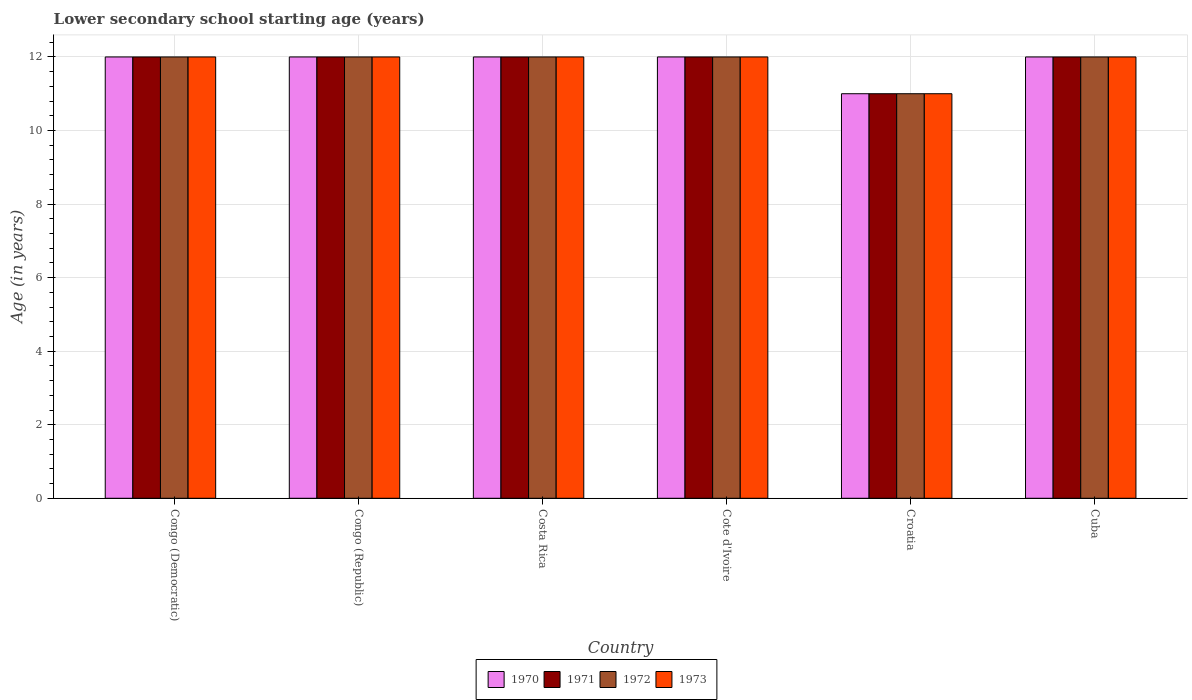How many different coloured bars are there?
Offer a terse response. 4. Are the number of bars on each tick of the X-axis equal?
Offer a very short reply. Yes. How many bars are there on the 4th tick from the left?
Offer a very short reply. 4. How many bars are there on the 4th tick from the right?
Offer a terse response. 4. What is the label of the 6th group of bars from the left?
Your answer should be very brief. Cuba. In how many cases, is the number of bars for a given country not equal to the number of legend labels?
Keep it short and to the point. 0. What is the lower secondary school starting age of children in 1972 in Congo (Democratic)?
Your answer should be very brief. 12. Across all countries, what is the maximum lower secondary school starting age of children in 1971?
Offer a very short reply. 12. In which country was the lower secondary school starting age of children in 1971 maximum?
Your answer should be very brief. Congo (Democratic). In which country was the lower secondary school starting age of children in 1970 minimum?
Keep it short and to the point. Croatia. What is the total lower secondary school starting age of children in 1973 in the graph?
Provide a succinct answer. 71. What is the difference between the lower secondary school starting age of children in 1971 in Costa Rica and that in Cote d'Ivoire?
Ensure brevity in your answer.  0. What is the average lower secondary school starting age of children in 1970 per country?
Ensure brevity in your answer.  11.83. What is the difference between the lower secondary school starting age of children of/in 1970 and lower secondary school starting age of children of/in 1973 in Congo (Democratic)?
Provide a succinct answer. 0. In how many countries, is the lower secondary school starting age of children in 1972 greater than 10.4 years?
Your response must be concise. 6. What is the ratio of the lower secondary school starting age of children in 1970 in Cote d'Ivoire to that in Cuba?
Keep it short and to the point. 1. Is the lower secondary school starting age of children in 1973 in Cote d'Ivoire less than that in Croatia?
Offer a very short reply. No. Is the difference between the lower secondary school starting age of children in 1970 in Costa Rica and Croatia greater than the difference between the lower secondary school starting age of children in 1973 in Costa Rica and Croatia?
Provide a succinct answer. No. In how many countries, is the lower secondary school starting age of children in 1973 greater than the average lower secondary school starting age of children in 1973 taken over all countries?
Offer a very short reply. 5. Is the sum of the lower secondary school starting age of children in 1972 in Costa Rica and Cuba greater than the maximum lower secondary school starting age of children in 1970 across all countries?
Make the answer very short. Yes. Is it the case that in every country, the sum of the lower secondary school starting age of children in 1973 and lower secondary school starting age of children in 1971 is greater than the sum of lower secondary school starting age of children in 1970 and lower secondary school starting age of children in 1972?
Ensure brevity in your answer.  No. What does the 4th bar from the right in Cuba represents?
Offer a terse response. 1970. How many bars are there?
Provide a succinct answer. 24. Are all the bars in the graph horizontal?
Keep it short and to the point. No. How many countries are there in the graph?
Offer a terse response. 6. What is the difference between two consecutive major ticks on the Y-axis?
Your response must be concise. 2. Does the graph contain any zero values?
Offer a very short reply. No. Where does the legend appear in the graph?
Make the answer very short. Bottom center. How many legend labels are there?
Give a very brief answer. 4. What is the title of the graph?
Make the answer very short. Lower secondary school starting age (years). Does "1986" appear as one of the legend labels in the graph?
Make the answer very short. No. What is the label or title of the X-axis?
Keep it short and to the point. Country. What is the label or title of the Y-axis?
Your response must be concise. Age (in years). What is the Age (in years) in 1973 in Congo (Republic)?
Give a very brief answer. 12. What is the Age (in years) in 1971 in Costa Rica?
Provide a succinct answer. 12. What is the Age (in years) of 1972 in Costa Rica?
Keep it short and to the point. 12. What is the Age (in years) in 1971 in Cuba?
Your answer should be compact. 12. What is the Age (in years) in 1973 in Cuba?
Provide a short and direct response. 12. Across all countries, what is the maximum Age (in years) of 1973?
Your answer should be very brief. 12. Across all countries, what is the minimum Age (in years) of 1970?
Offer a terse response. 11. Across all countries, what is the minimum Age (in years) of 1971?
Ensure brevity in your answer.  11. Across all countries, what is the minimum Age (in years) of 1973?
Provide a succinct answer. 11. What is the total Age (in years) in 1970 in the graph?
Your answer should be very brief. 71. What is the total Age (in years) of 1972 in the graph?
Give a very brief answer. 71. What is the difference between the Age (in years) of 1970 in Congo (Democratic) and that in Congo (Republic)?
Provide a short and direct response. 0. What is the difference between the Age (in years) of 1971 in Congo (Democratic) and that in Congo (Republic)?
Make the answer very short. 0. What is the difference between the Age (in years) in 1972 in Congo (Democratic) and that in Congo (Republic)?
Give a very brief answer. 0. What is the difference between the Age (in years) of 1973 in Congo (Democratic) and that in Congo (Republic)?
Your answer should be very brief. 0. What is the difference between the Age (in years) in 1970 in Congo (Democratic) and that in Costa Rica?
Your response must be concise. 0. What is the difference between the Age (in years) of 1972 in Congo (Democratic) and that in Costa Rica?
Offer a very short reply. 0. What is the difference between the Age (in years) of 1971 in Congo (Democratic) and that in Cote d'Ivoire?
Provide a short and direct response. 0. What is the difference between the Age (in years) of 1972 in Congo (Democratic) and that in Cote d'Ivoire?
Offer a very short reply. 0. What is the difference between the Age (in years) in 1973 in Congo (Democratic) and that in Cote d'Ivoire?
Offer a very short reply. 0. What is the difference between the Age (in years) of 1971 in Congo (Democratic) and that in Croatia?
Your answer should be very brief. 1. What is the difference between the Age (in years) in 1972 in Congo (Democratic) and that in Croatia?
Your answer should be very brief. 1. What is the difference between the Age (in years) in 1973 in Congo (Democratic) and that in Croatia?
Give a very brief answer. 1. What is the difference between the Age (in years) in 1970 in Congo (Democratic) and that in Cuba?
Your response must be concise. 0. What is the difference between the Age (in years) of 1971 in Congo (Democratic) and that in Cuba?
Your answer should be very brief. 0. What is the difference between the Age (in years) in 1972 in Congo (Democratic) and that in Cuba?
Keep it short and to the point. 0. What is the difference between the Age (in years) in 1970 in Congo (Republic) and that in Costa Rica?
Offer a very short reply. 0. What is the difference between the Age (in years) in 1972 in Congo (Republic) and that in Costa Rica?
Your answer should be compact. 0. What is the difference between the Age (in years) in 1973 in Congo (Republic) and that in Costa Rica?
Offer a very short reply. 0. What is the difference between the Age (in years) in 1973 in Congo (Republic) and that in Cote d'Ivoire?
Provide a short and direct response. 0. What is the difference between the Age (in years) of 1970 in Congo (Republic) and that in Croatia?
Offer a very short reply. 1. What is the difference between the Age (in years) of 1971 in Congo (Republic) and that in Croatia?
Provide a short and direct response. 1. What is the difference between the Age (in years) of 1970 in Congo (Republic) and that in Cuba?
Your answer should be compact. 0. What is the difference between the Age (in years) of 1971 in Congo (Republic) and that in Cuba?
Give a very brief answer. 0. What is the difference between the Age (in years) of 1972 in Congo (Republic) and that in Cuba?
Your answer should be very brief. 0. What is the difference between the Age (in years) in 1973 in Congo (Republic) and that in Cuba?
Offer a terse response. 0. What is the difference between the Age (in years) of 1971 in Costa Rica and that in Cote d'Ivoire?
Provide a succinct answer. 0. What is the difference between the Age (in years) in 1973 in Costa Rica and that in Cote d'Ivoire?
Provide a short and direct response. 0. What is the difference between the Age (in years) of 1972 in Costa Rica and that in Cuba?
Give a very brief answer. 0. What is the difference between the Age (in years) in 1970 in Cote d'Ivoire and that in Croatia?
Offer a terse response. 1. What is the difference between the Age (in years) in 1971 in Cote d'Ivoire and that in Croatia?
Make the answer very short. 1. What is the difference between the Age (in years) of 1972 in Cote d'Ivoire and that in Croatia?
Offer a terse response. 1. What is the difference between the Age (in years) in 1971 in Cote d'Ivoire and that in Cuba?
Your answer should be compact. 0. What is the difference between the Age (in years) of 1973 in Cote d'Ivoire and that in Cuba?
Give a very brief answer. 0. What is the difference between the Age (in years) of 1970 in Croatia and that in Cuba?
Your answer should be very brief. -1. What is the difference between the Age (in years) in 1972 in Croatia and that in Cuba?
Provide a succinct answer. -1. What is the difference between the Age (in years) of 1971 in Congo (Democratic) and the Age (in years) of 1972 in Congo (Republic)?
Your response must be concise. 0. What is the difference between the Age (in years) in 1970 in Congo (Democratic) and the Age (in years) in 1973 in Costa Rica?
Your answer should be compact. 0. What is the difference between the Age (in years) in 1970 in Congo (Democratic) and the Age (in years) in 1971 in Cote d'Ivoire?
Provide a succinct answer. 0. What is the difference between the Age (in years) of 1970 in Congo (Democratic) and the Age (in years) of 1972 in Cote d'Ivoire?
Ensure brevity in your answer.  0. What is the difference between the Age (in years) of 1970 in Congo (Democratic) and the Age (in years) of 1973 in Cote d'Ivoire?
Provide a short and direct response. 0. What is the difference between the Age (in years) of 1971 in Congo (Democratic) and the Age (in years) of 1972 in Cote d'Ivoire?
Offer a terse response. 0. What is the difference between the Age (in years) of 1972 in Congo (Democratic) and the Age (in years) of 1973 in Cote d'Ivoire?
Make the answer very short. 0. What is the difference between the Age (in years) of 1970 in Congo (Democratic) and the Age (in years) of 1972 in Croatia?
Make the answer very short. 1. What is the difference between the Age (in years) of 1970 in Congo (Democratic) and the Age (in years) of 1973 in Croatia?
Provide a short and direct response. 1. What is the difference between the Age (in years) in 1970 in Congo (Democratic) and the Age (in years) in 1971 in Cuba?
Your answer should be very brief. 0. What is the difference between the Age (in years) in 1970 in Congo (Democratic) and the Age (in years) in 1972 in Cuba?
Ensure brevity in your answer.  0. What is the difference between the Age (in years) of 1971 in Congo (Democratic) and the Age (in years) of 1973 in Cuba?
Provide a short and direct response. 0. What is the difference between the Age (in years) of 1972 in Congo (Democratic) and the Age (in years) of 1973 in Cuba?
Ensure brevity in your answer.  0. What is the difference between the Age (in years) in 1970 in Congo (Republic) and the Age (in years) in 1972 in Costa Rica?
Offer a very short reply. 0. What is the difference between the Age (in years) in 1970 in Congo (Republic) and the Age (in years) in 1973 in Costa Rica?
Provide a short and direct response. 0. What is the difference between the Age (in years) in 1970 in Congo (Republic) and the Age (in years) in 1971 in Cote d'Ivoire?
Provide a short and direct response. 0. What is the difference between the Age (in years) in 1971 in Congo (Republic) and the Age (in years) in 1973 in Cote d'Ivoire?
Your answer should be very brief. 0. What is the difference between the Age (in years) of 1971 in Congo (Republic) and the Age (in years) of 1972 in Croatia?
Offer a terse response. 1. What is the difference between the Age (in years) in 1971 in Congo (Republic) and the Age (in years) in 1973 in Croatia?
Give a very brief answer. 1. What is the difference between the Age (in years) of 1971 in Congo (Republic) and the Age (in years) of 1972 in Cuba?
Your answer should be compact. 0. What is the difference between the Age (in years) of 1971 in Congo (Republic) and the Age (in years) of 1973 in Cuba?
Make the answer very short. 0. What is the difference between the Age (in years) in 1970 in Costa Rica and the Age (in years) in 1973 in Cote d'Ivoire?
Your response must be concise. 0. What is the difference between the Age (in years) of 1971 in Costa Rica and the Age (in years) of 1972 in Cote d'Ivoire?
Provide a short and direct response. 0. What is the difference between the Age (in years) of 1971 in Costa Rica and the Age (in years) of 1973 in Cote d'Ivoire?
Your response must be concise. 0. What is the difference between the Age (in years) in 1970 in Costa Rica and the Age (in years) in 1972 in Croatia?
Provide a short and direct response. 1. What is the difference between the Age (in years) of 1970 in Costa Rica and the Age (in years) of 1973 in Croatia?
Make the answer very short. 1. What is the difference between the Age (in years) of 1971 in Costa Rica and the Age (in years) of 1973 in Croatia?
Your answer should be very brief. 1. What is the difference between the Age (in years) of 1972 in Costa Rica and the Age (in years) of 1973 in Croatia?
Your response must be concise. 1. What is the difference between the Age (in years) of 1970 in Costa Rica and the Age (in years) of 1973 in Cuba?
Keep it short and to the point. 0. What is the difference between the Age (in years) of 1971 in Costa Rica and the Age (in years) of 1972 in Cuba?
Offer a terse response. 0. What is the difference between the Age (in years) of 1971 in Costa Rica and the Age (in years) of 1973 in Cuba?
Your answer should be compact. 0. What is the difference between the Age (in years) in 1970 in Cote d'Ivoire and the Age (in years) in 1971 in Croatia?
Offer a very short reply. 1. What is the difference between the Age (in years) in 1971 in Cote d'Ivoire and the Age (in years) in 1972 in Croatia?
Your response must be concise. 1. What is the difference between the Age (in years) in 1970 in Cote d'Ivoire and the Age (in years) in 1971 in Cuba?
Ensure brevity in your answer.  0. What is the difference between the Age (in years) in 1970 in Cote d'Ivoire and the Age (in years) in 1973 in Cuba?
Ensure brevity in your answer.  0. What is the difference between the Age (in years) of 1971 in Cote d'Ivoire and the Age (in years) of 1972 in Cuba?
Offer a terse response. 0. What is the average Age (in years) of 1970 per country?
Provide a succinct answer. 11.83. What is the average Age (in years) of 1971 per country?
Make the answer very short. 11.83. What is the average Age (in years) in 1972 per country?
Your answer should be compact. 11.83. What is the average Age (in years) in 1973 per country?
Your response must be concise. 11.83. What is the difference between the Age (in years) in 1970 and Age (in years) in 1971 in Congo (Democratic)?
Keep it short and to the point. 0. What is the difference between the Age (in years) in 1970 and Age (in years) in 1972 in Congo (Democratic)?
Your answer should be compact. 0. What is the difference between the Age (in years) of 1971 and Age (in years) of 1973 in Congo (Republic)?
Offer a terse response. 0. What is the difference between the Age (in years) in 1972 and Age (in years) in 1973 in Congo (Republic)?
Provide a succinct answer. 0. What is the difference between the Age (in years) in 1970 and Age (in years) in 1972 in Costa Rica?
Your answer should be compact. 0. What is the difference between the Age (in years) in 1972 and Age (in years) in 1973 in Costa Rica?
Your answer should be very brief. 0. What is the difference between the Age (in years) of 1970 and Age (in years) of 1971 in Cote d'Ivoire?
Make the answer very short. 0. What is the difference between the Age (in years) of 1970 and Age (in years) of 1972 in Cote d'Ivoire?
Keep it short and to the point. 0. What is the difference between the Age (in years) of 1970 and Age (in years) of 1973 in Cote d'Ivoire?
Make the answer very short. 0. What is the difference between the Age (in years) of 1971 and Age (in years) of 1972 in Cote d'Ivoire?
Give a very brief answer. 0. What is the difference between the Age (in years) of 1970 and Age (in years) of 1973 in Croatia?
Provide a short and direct response. 0. What is the difference between the Age (in years) in 1970 and Age (in years) in 1971 in Cuba?
Provide a short and direct response. 0. What is the difference between the Age (in years) of 1970 and Age (in years) of 1972 in Cuba?
Give a very brief answer. 0. What is the difference between the Age (in years) of 1970 and Age (in years) of 1973 in Cuba?
Give a very brief answer. 0. What is the difference between the Age (in years) in 1971 and Age (in years) in 1973 in Cuba?
Your answer should be very brief. 0. What is the ratio of the Age (in years) in 1970 in Congo (Democratic) to that in Costa Rica?
Keep it short and to the point. 1. What is the ratio of the Age (in years) in 1973 in Congo (Democratic) to that in Costa Rica?
Provide a succinct answer. 1. What is the ratio of the Age (in years) of 1971 in Congo (Democratic) to that in Cote d'Ivoire?
Offer a terse response. 1. What is the ratio of the Age (in years) of 1973 in Congo (Democratic) to that in Cote d'Ivoire?
Your answer should be compact. 1. What is the ratio of the Age (in years) of 1970 in Congo (Democratic) to that in Cuba?
Ensure brevity in your answer.  1. What is the ratio of the Age (in years) in 1971 in Congo (Democratic) to that in Cuba?
Keep it short and to the point. 1. What is the ratio of the Age (in years) in 1972 in Congo (Democratic) to that in Cuba?
Offer a very short reply. 1. What is the ratio of the Age (in years) of 1973 in Congo (Democratic) to that in Cuba?
Your response must be concise. 1. What is the ratio of the Age (in years) in 1971 in Congo (Republic) to that in Costa Rica?
Give a very brief answer. 1. What is the ratio of the Age (in years) of 1972 in Congo (Republic) to that in Costa Rica?
Give a very brief answer. 1. What is the ratio of the Age (in years) of 1970 in Congo (Republic) to that in Croatia?
Give a very brief answer. 1.09. What is the ratio of the Age (in years) of 1971 in Congo (Republic) to that in Croatia?
Offer a very short reply. 1.09. What is the ratio of the Age (in years) of 1973 in Congo (Republic) to that in Croatia?
Ensure brevity in your answer.  1.09. What is the ratio of the Age (in years) in 1970 in Congo (Republic) to that in Cuba?
Provide a short and direct response. 1. What is the ratio of the Age (in years) in 1972 in Congo (Republic) to that in Cuba?
Give a very brief answer. 1. What is the ratio of the Age (in years) in 1973 in Congo (Republic) to that in Cuba?
Provide a short and direct response. 1. What is the ratio of the Age (in years) in 1971 in Costa Rica to that in Cote d'Ivoire?
Your answer should be very brief. 1. What is the ratio of the Age (in years) of 1971 in Costa Rica to that in Croatia?
Provide a short and direct response. 1.09. What is the ratio of the Age (in years) of 1972 in Costa Rica to that in Cuba?
Make the answer very short. 1. What is the ratio of the Age (in years) of 1971 in Cote d'Ivoire to that in Croatia?
Provide a short and direct response. 1.09. What is the ratio of the Age (in years) in 1972 in Cote d'Ivoire to that in Croatia?
Keep it short and to the point. 1.09. What is the ratio of the Age (in years) of 1973 in Cote d'Ivoire to that in Croatia?
Give a very brief answer. 1.09. What is the ratio of the Age (in years) of 1971 in Cote d'Ivoire to that in Cuba?
Make the answer very short. 1. What is the ratio of the Age (in years) of 1972 in Cote d'Ivoire to that in Cuba?
Offer a very short reply. 1. What is the ratio of the Age (in years) of 1970 in Croatia to that in Cuba?
Your answer should be very brief. 0.92. What is the ratio of the Age (in years) of 1971 in Croatia to that in Cuba?
Your response must be concise. 0.92. What is the ratio of the Age (in years) in 1972 in Croatia to that in Cuba?
Give a very brief answer. 0.92. What is the ratio of the Age (in years) in 1973 in Croatia to that in Cuba?
Keep it short and to the point. 0.92. What is the difference between the highest and the lowest Age (in years) in 1970?
Keep it short and to the point. 1. What is the difference between the highest and the lowest Age (in years) in 1971?
Make the answer very short. 1. What is the difference between the highest and the lowest Age (in years) of 1972?
Provide a short and direct response. 1. What is the difference between the highest and the lowest Age (in years) of 1973?
Ensure brevity in your answer.  1. 